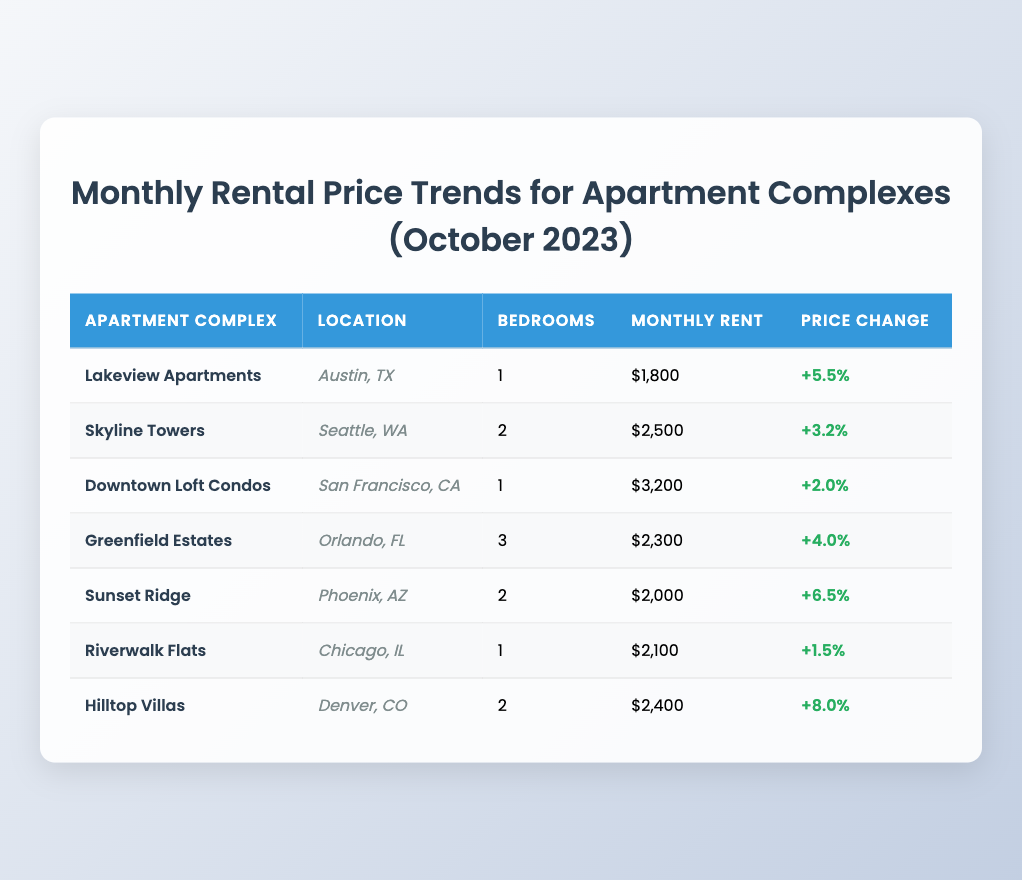What is the monthly rent for Lakeview Apartments? The table shows that Lakeview Apartments has a monthly rent of $1,800.
Answer: $1,800 Which apartment complex has the highest monthly rent? By comparing the monthly rents listed in the table, Downtown Loft Condos has the highest rent at $3,200.
Answer: Downtown Loft Condos What is the price change percentage for Hilltop Villas? According to the table, Hilltop Villas has a price change percentage of +8.0%.
Answer: +8.0% What is the average monthly rent across all listed apartment complexes? The monthly rents are $1,800, $2,500, $3,200, $2,300, $2,000, $2,100, and $2,400. Summing these values gives $14,300. Dividing that by 7 (the number of complexes) results in an average monthly rent of $2,043.
Answer: $2,043 Is the price change for Riverwalk Flats positive? The table indicates that Riverwalk Flats has a price change of +1.5%, which is positive.
Answer: Yes Which location has the apartment complex with the lowest monthly rent? By reviewing the rents, Lakeview Apartments at Austin, TX has the lowest monthly rent of $1,800 compared to others.
Answer: Austin, TX How much more expensive is the monthly rent at Hilltop Villas compared to Sunset Ridge? Hilltop Villas has a monthly rent of $2,400 and Sunset Ridge has a rent of $2,000. Subtracting these gives $2,400 - $2,000 = $400, meaning Hilltop Villas is $400 more expensive.
Answer: $400 How many apartments have a price change percentage above 5%? Analyzing the table's price change percentages, Lakeview Apartments, Sunset Ridge, and Hilltop Villas show percentages above 5%, which makes a total of 3 apartments.
Answer: 3 Is it true that all apartment complexes have a price change percentage greater than 0%? Comparing the data reveals all apartments have positive price change percentages, confirming the statement as true.
Answer: Yes 